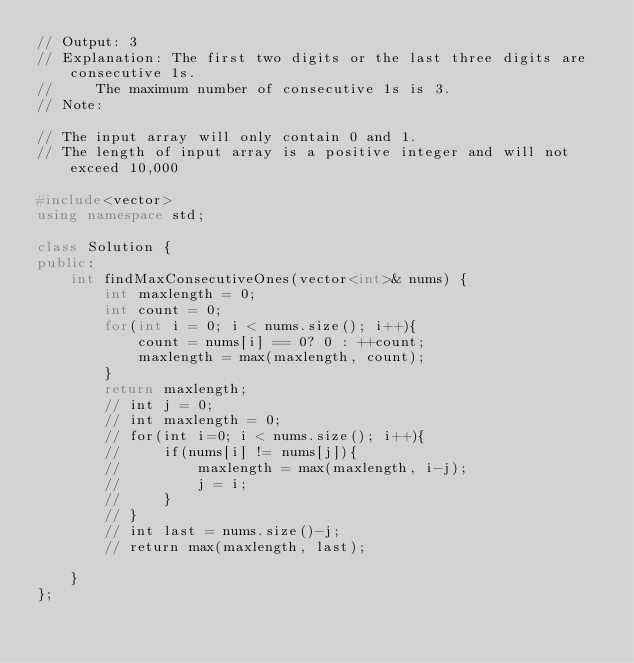<code> <loc_0><loc_0><loc_500><loc_500><_C++_>// Output: 3
// Explanation: The first two digits or the last three digits are consecutive 1s.
//     The maximum number of consecutive 1s is 3.
// Note:

// The input array will only contain 0 and 1.
// The length of input array is a positive integer and will not exceed 10,000

#include<vector>
using namespace std;

class Solution {
public:
    int findMaxConsecutiveOnes(vector<int>& nums) {
        int maxlength = 0;
        int count = 0;
        for(int i = 0; i < nums.size(); i++){
            count = nums[i] == 0? 0 : ++count;
            maxlength = max(maxlength, count);
        }
        return maxlength;
        // int j = 0;
        // int maxlength = 0;
        // for(int i=0; i < nums.size(); i++){
        //     if(nums[i] != nums[j]){
        //         maxlength = max(maxlength, i-j);
        //         j = i;
        //     }
        // }
        // int last = nums.size()-j;
        // return max(maxlength, last);

    }
};</code> 